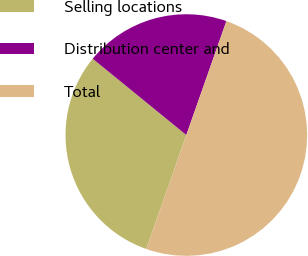<chart> <loc_0><loc_0><loc_500><loc_500><pie_chart><fcel>Selling locations<fcel>Distribution center and<fcel>Total<nl><fcel>30.5%<fcel>19.5%<fcel>50.0%<nl></chart> 